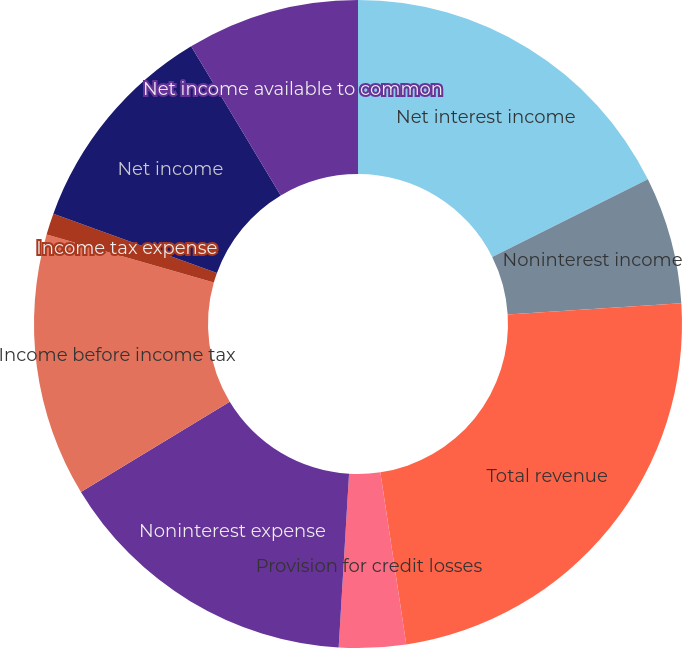Convert chart to OTSL. <chart><loc_0><loc_0><loc_500><loc_500><pie_chart><fcel>Net interest income<fcel>Noninterest income<fcel>Total revenue<fcel>Provision for credit losses<fcel>Noninterest expense<fcel>Income before income tax<fcel>Income tax expense<fcel>Net income<fcel>Net income available to common<nl><fcel>17.63%<fcel>6.35%<fcel>23.64%<fcel>3.33%<fcel>15.38%<fcel>13.12%<fcel>1.08%<fcel>10.86%<fcel>8.61%<nl></chart> 